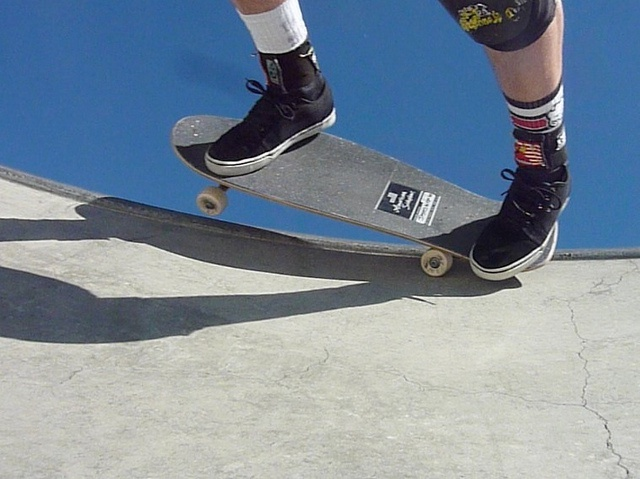Describe the objects in this image and their specific colors. I can see people in blue, black, gray, darkgray, and lightgray tones and skateboard in blue, gray, and black tones in this image. 